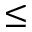<formula> <loc_0><loc_0><loc_500><loc_500>\leq</formula> 